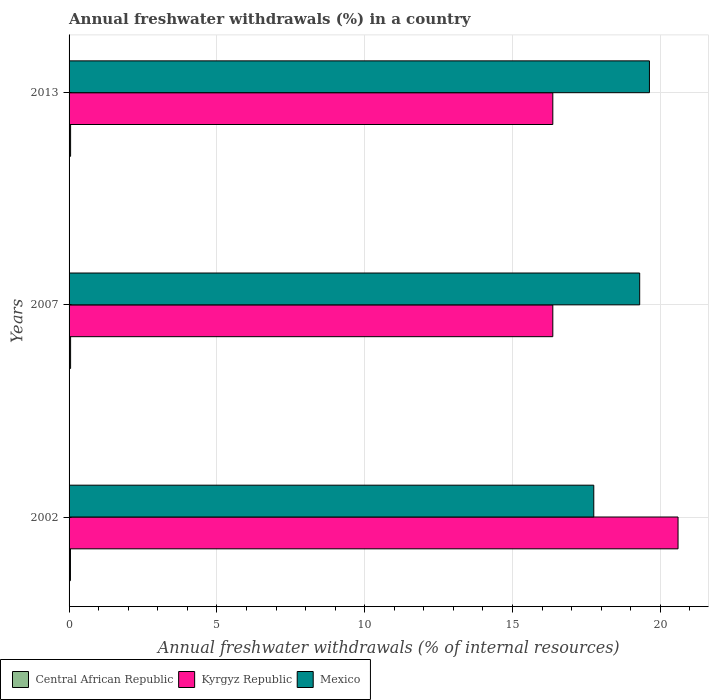How many different coloured bars are there?
Keep it short and to the point. 3. Are the number of bars on each tick of the Y-axis equal?
Your answer should be very brief. Yes. How many bars are there on the 3rd tick from the top?
Give a very brief answer. 3. What is the percentage of annual freshwater withdrawals in Mexico in 2013?
Ensure brevity in your answer.  19.63. Across all years, what is the maximum percentage of annual freshwater withdrawals in Kyrgyz Republic?
Your answer should be very brief. 20.6. Across all years, what is the minimum percentage of annual freshwater withdrawals in Central African Republic?
Keep it short and to the point. 0.05. In which year was the percentage of annual freshwater withdrawals in Kyrgyz Republic maximum?
Provide a succinct answer. 2002. In which year was the percentage of annual freshwater withdrawals in Mexico minimum?
Give a very brief answer. 2002. What is the total percentage of annual freshwater withdrawals in Central African Republic in the graph?
Ensure brevity in your answer.  0.15. What is the difference between the percentage of annual freshwater withdrawals in Mexico in 2007 and that in 2013?
Offer a terse response. -0.33. What is the difference between the percentage of annual freshwater withdrawals in Mexico in 2007 and the percentage of annual freshwater withdrawals in Kyrgyz Republic in 2002?
Your answer should be very brief. -1.3. What is the average percentage of annual freshwater withdrawals in Mexico per year?
Give a very brief answer. 18.9. In the year 2002, what is the difference between the percentage of annual freshwater withdrawals in Kyrgyz Republic and percentage of annual freshwater withdrawals in Central African Republic?
Give a very brief answer. 20.55. What is the ratio of the percentage of annual freshwater withdrawals in Mexico in 2002 to that in 2013?
Give a very brief answer. 0.9. Is the percentage of annual freshwater withdrawals in Central African Republic in 2002 less than that in 2013?
Your response must be concise. Yes. What is the difference between the highest and the second highest percentage of annual freshwater withdrawals in Mexico?
Offer a terse response. 0.33. What is the difference between the highest and the lowest percentage of annual freshwater withdrawals in Mexico?
Provide a short and direct response. 1.88. Is the sum of the percentage of annual freshwater withdrawals in Mexico in 2002 and 2013 greater than the maximum percentage of annual freshwater withdrawals in Kyrgyz Republic across all years?
Offer a terse response. Yes. What does the 2nd bar from the top in 2013 represents?
Provide a succinct answer. Kyrgyz Republic. What does the 1st bar from the bottom in 2002 represents?
Offer a terse response. Central African Republic. Are all the bars in the graph horizontal?
Give a very brief answer. Yes. Are the values on the major ticks of X-axis written in scientific E-notation?
Offer a very short reply. No. Does the graph contain any zero values?
Your answer should be very brief. No. Does the graph contain grids?
Your answer should be compact. Yes. Where does the legend appear in the graph?
Keep it short and to the point. Bottom left. What is the title of the graph?
Your answer should be very brief. Annual freshwater withdrawals (%) in a country. What is the label or title of the X-axis?
Offer a terse response. Annual freshwater withdrawals (% of internal resources). What is the Annual freshwater withdrawals (% of internal resources) in Central African Republic in 2002?
Offer a terse response. 0.05. What is the Annual freshwater withdrawals (% of internal resources) in Kyrgyz Republic in 2002?
Your response must be concise. 20.6. What is the Annual freshwater withdrawals (% of internal resources) of Mexico in 2002?
Offer a very short reply. 17.75. What is the Annual freshwater withdrawals (% of internal resources) in Central African Republic in 2007?
Give a very brief answer. 0.05. What is the Annual freshwater withdrawals (% of internal resources) of Kyrgyz Republic in 2007?
Offer a very short reply. 16.36. What is the Annual freshwater withdrawals (% of internal resources) in Mexico in 2007?
Provide a succinct answer. 19.3. What is the Annual freshwater withdrawals (% of internal resources) of Central African Republic in 2013?
Offer a very short reply. 0.05. What is the Annual freshwater withdrawals (% of internal resources) of Kyrgyz Republic in 2013?
Make the answer very short. 16.36. What is the Annual freshwater withdrawals (% of internal resources) in Mexico in 2013?
Provide a short and direct response. 19.63. Across all years, what is the maximum Annual freshwater withdrawals (% of internal resources) of Central African Republic?
Make the answer very short. 0.05. Across all years, what is the maximum Annual freshwater withdrawals (% of internal resources) in Kyrgyz Republic?
Offer a very short reply. 20.6. Across all years, what is the maximum Annual freshwater withdrawals (% of internal resources) in Mexico?
Your answer should be very brief. 19.63. Across all years, what is the minimum Annual freshwater withdrawals (% of internal resources) in Central African Republic?
Your answer should be compact. 0.05. Across all years, what is the minimum Annual freshwater withdrawals (% of internal resources) in Kyrgyz Republic?
Your answer should be compact. 16.36. Across all years, what is the minimum Annual freshwater withdrawals (% of internal resources) in Mexico?
Your answer should be compact. 17.75. What is the total Annual freshwater withdrawals (% of internal resources) of Central African Republic in the graph?
Your answer should be very brief. 0.15. What is the total Annual freshwater withdrawals (% of internal resources) of Kyrgyz Republic in the graph?
Give a very brief answer. 53.33. What is the total Annual freshwater withdrawals (% of internal resources) in Mexico in the graph?
Your answer should be compact. 56.69. What is the difference between the Annual freshwater withdrawals (% of internal resources) in Central African Republic in 2002 and that in 2007?
Make the answer very short. -0. What is the difference between the Annual freshwater withdrawals (% of internal resources) of Kyrgyz Republic in 2002 and that in 2007?
Keep it short and to the point. 4.24. What is the difference between the Annual freshwater withdrawals (% of internal resources) in Mexico in 2002 and that in 2007?
Your answer should be compact. -1.55. What is the difference between the Annual freshwater withdrawals (% of internal resources) in Central African Republic in 2002 and that in 2013?
Offer a very short reply. -0. What is the difference between the Annual freshwater withdrawals (% of internal resources) in Kyrgyz Republic in 2002 and that in 2013?
Keep it short and to the point. 4.24. What is the difference between the Annual freshwater withdrawals (% of internal resources) of Mexico in 2002 and that in 2013?
Keep it short and to the point. -1.88. What is the difference between the Annual freshwater withdrawals (% of internal resources) of Central African Republic in 2007 and that in 2013?
Your response must be concise. 0. What is the difference between the Annual freshwater withdrawals (% of internal resources) of Mexico in 2007 and that in 2013?
Make the answer very short. -0.33. What is the difference between the Annual freshwater withdrawals (% of internal resources) of Central African Republic in 2002 and the Annual freshwater withdrawals (% of internal resources) of Kyrgyz Republic in 2007?
Make the answer very short. -16.32. What is the difference between the Annual freshwater withdrawals (% of internal resources) of Central African Republic in 2002 and the Annual freshwater withdrawals (% of internal resources) of Mexico in 2007?
Your answer should be very brief. -19.26. What is the difference between the Annual freshwater withdrawals (% of internal resources) in Kyrgyz Republic in 2002 and the Annual freshwater withdrawals (% of internal resources) in Mexico in 2007?
Offer a terse response. 1.3. What is the difference between the Annual freshwater withdrawals (% of internal resources) of Central African Republic in 2002 and the Annual freshwater withdrawals (% of internal resources) of Kyrgyz Republic in 2013?
Offer a terse response. -16.32. What is the difference between the Annual freshwater withdrawals (% of internal resources) in Central African Republic in 2002 and the Annual freshwater withdrawals (% of internal resources) in Mexico in 2013?
Ensure brevity in your answer.  -19.59. What is the difference between the Annual freshwater withdrawals (% of internal resources) in Kyrgyz Republic in 2002 and the Annual freshwater withdrawals (% of internal resources) in Mexico in 2013?
Provide a short and direct response. 0.97. What is the difference between the Annual freshwater withdrawals (% of internal resources) in Central African Republic in 2007 and the Annual freshwater withdrawals (% of internal resources) in Kyrgyz Republic in 2013?
Ensure brevity in your answer.  -16.31. What is the difference between the Annual freshwater withdrawals (% of internal resources) in Central African Republic in 2007 and the Annual freshwater withdrawals (% of internal resources) in Mexico in 2013?
Keep it short and to the point. -19.58. What is the difference between the Annual freshwater withdrawals (% of internal resources) of Kyrgyz Republic in 2007 and the Annual freshwater withdrawals (% of internal resources) of Mexico in 2013?
Make the answer very short. -3.27. What is the average Annual freshwater withdrawals (% of internal resources) of Central African Republic per year?
Provide a succinct answer. 0.05. What is the average Annual freshwater withdrawals (% of internal resources) in Kyrgyz Republic per year?
Ensure brevity in your answer.  17.78. What is the average Annual freshwater withdrawals (% of internal resources) of Mexico per year?
Give a very brief answer. 18.9. In the year 2002, what is the difference between the Annual freshwater withdrawals (% of internal resources) of Central African Republic and Annual freshwater withdrawals (% of internal resources) of Kyrgyz Republic?
Offer a terse response. -20.55. In the year 2002, what is the difference between the Annual freshwater withdrawals (% of internal resources) of Central African Republic and Annual freshwater withdrawals (% of internal resources) of Mexico?
Your response must be concise. -17.7. In the year 2002, what is the difference between the Annual freshwater withdrawals (% of internal resources) of Kyrgyz Republic and Annual freshwater withdrawals (% of internal resources) of Mexico?
Offer a very short reply. 2.85. In the year 2007, what is the difference between the Annual freshwater withdrawals (% of internal resources) of Central African Republic and Annual freshwater withdrawals (% of internal resources) of Kyrgyz Republic?
Keep it short and to the point. -16.31. In the year 2007, what is the difference between the Annual freshwater withdrawals (% of internal resources) of Central African Republic and Annual freshwater withdrawals (% of internal resources) of Mexico?
Keep it short and to the point. -19.25. In the year 2007, what is the difference between the Annual freshwater withdrawals (% of internal resources) of Kyrgyz Republic and Annual freshwater withdrawals (% of internal resources) of Mexico?
Provide a short and direct response. -2.94. In the year 2013, what is the difference between the Annual freshwater withdrawals (% of internal resources) in Central African Republic and Annual freshwater withdrawals (% of internal resources) in Kyrgyz Republic?
Your answer should be compact. -16.31. In the year 2013, what is the difference between the Annual freshwater withdrawals (% of internal resources) in Central African Republic and Annual freshwater withdrawals (% of internal resources) in Mexico?
Offer a very short reply. -19.58. In the year 2013, what is the difference between the Annual freshwater withdrawals (% of internal resources) in Kyrgyz Republic and Annual freshwater withdrawals (% of internal resources) in Mexico?
Provide a succinct answer. -3.27. What is the ratio of the Annual freshwater withdrawals (% of internal resources) of Central African Republic in 2002 to that in 2007?
Offer a very short reply. 0.91. What is the ratio of the Annual freshwater withdrawals (% of internal resources) in Kyrgyz Republic in 2002 to that in 2007?
Make the answer very short. 1.26. What is the ratio of the Annual freshwater withdrawals (% of internal resources) of Mexico in 2002 to that in 2007?
Make the answer very short. 0.92. What is the ratio of the Annual freshwater withdrawals (% of internal resources) of Central African Republic in 2002 to that in 2013?
Offer a terse response. 0.91. What is the ratio of the Annual freshwater withdrawals (% of internal resources) of Kyrgyz Republic in 2002 to that in 2013?
Your response must be concise. 1.26. What is the ratio of the Annual freshwater withdrawals (% of internal resources) of Mexico in 2002 to that in 2013?
Make the answer very short. 0.9. What is the ratio of the Annual freshwater withdrawals (% of internal resources) in Central African Republic in 2007 to that in 2013?
Offer a very short reply. 1. What is the ratio of the Annual freshwater withdrawals (% of internal resources) of Mexico in 2007 to that in 2013?
Keep it short and to the point. 0.98. What is the difference between the highest and the second highest Annual freshwater withdrawals (% of internal resources) of Central African Republic?
Provide a short and direct response. 0. What is the difference between the highest and the second highest Annual freshwater withdrawals (% of internal resources) in Kyrgyz Republic?
Provide a short and direct response. 4.24. What is the difference between the highest and the second highest Annual freshwater withdrawals (% of internal resources) in Mexico?
Your response must be concise. 0.33. What is the difference between the highest and the lowest Annual freshwater withdrawals (% of internal resources) of Central African Republic?
Your response must be concise. 0. What is the difference between the highest and the lowest Annual freshwater withdrawals (% of internal resources) in Kyrgyz Republic?
Your response must be concise. 4.24. What is the difference between the highest and the lowest Annual freshwater withdrawals (% of internal resources) in Mexico?
Offer a very short reply. 1.88. 